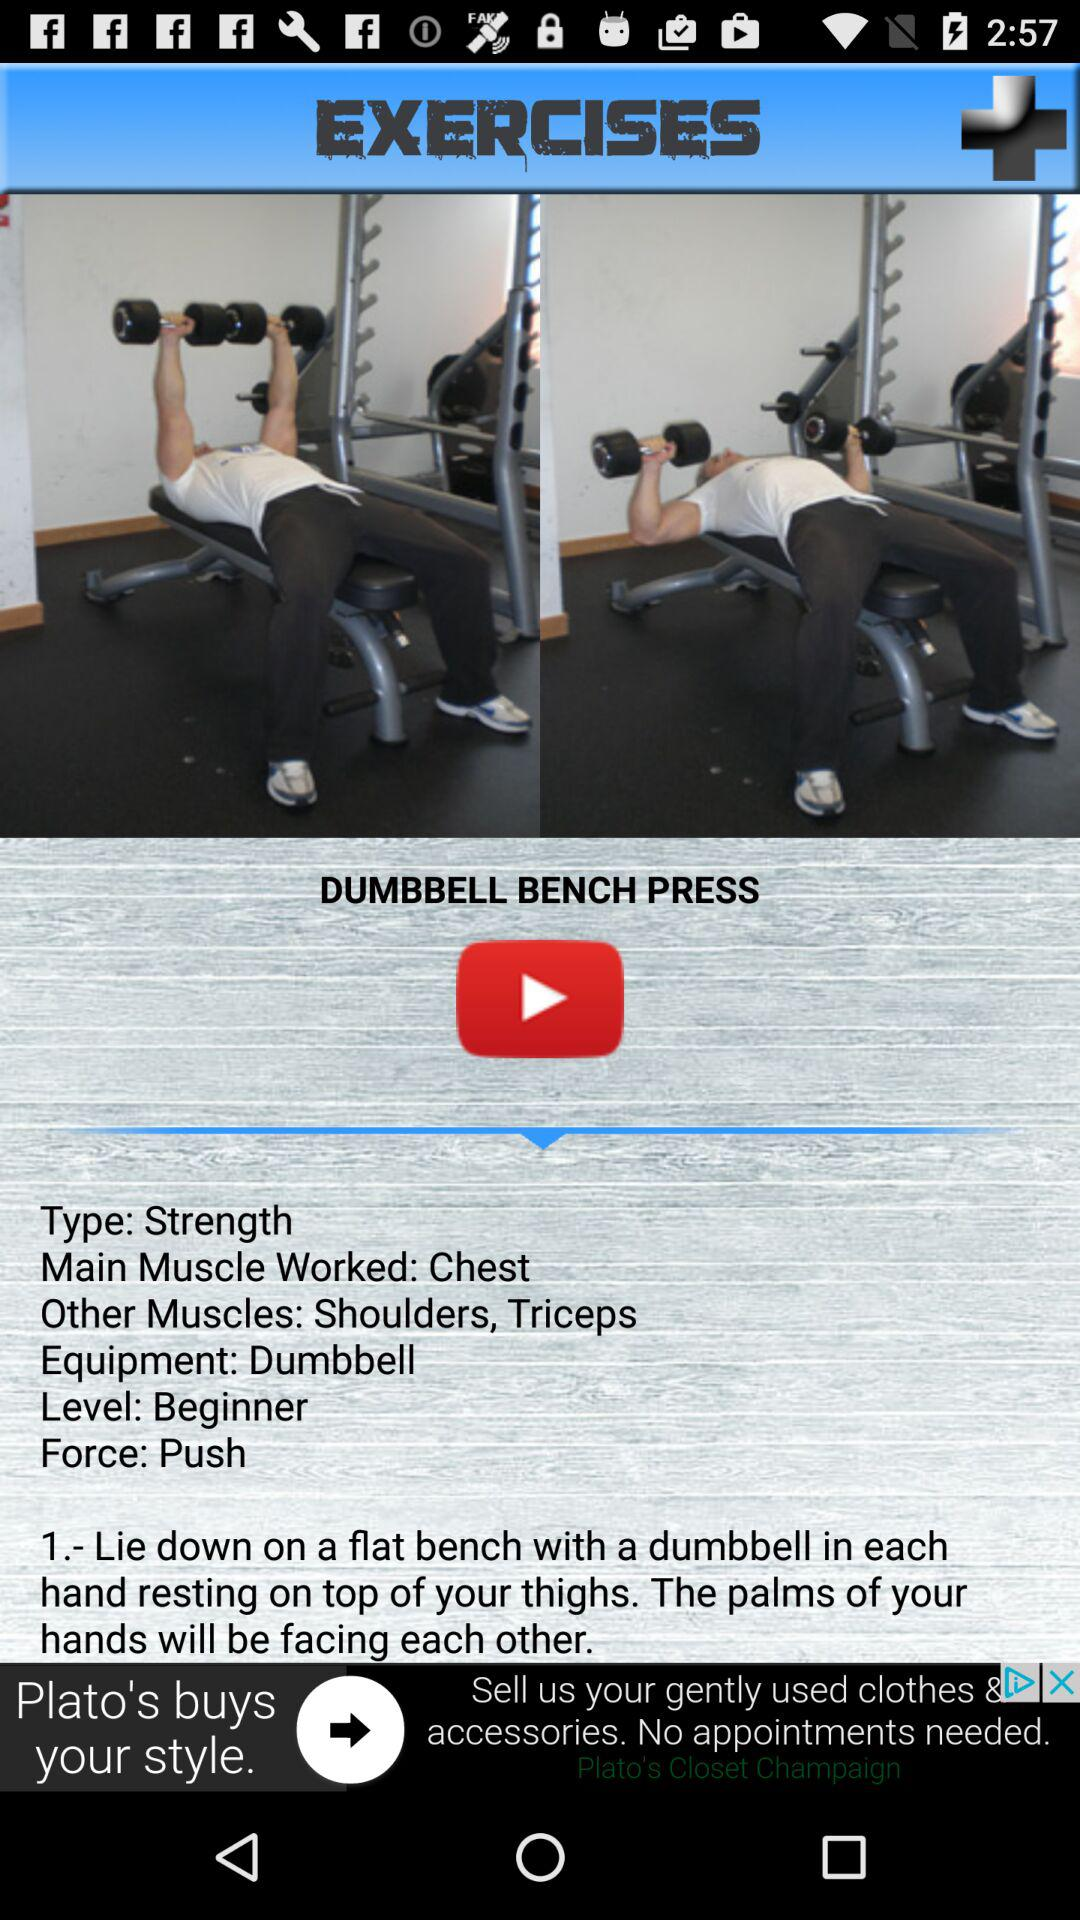How many steps are there in the dumbbell bench press exercise?
Answer the question using a single word or phrase. 1 